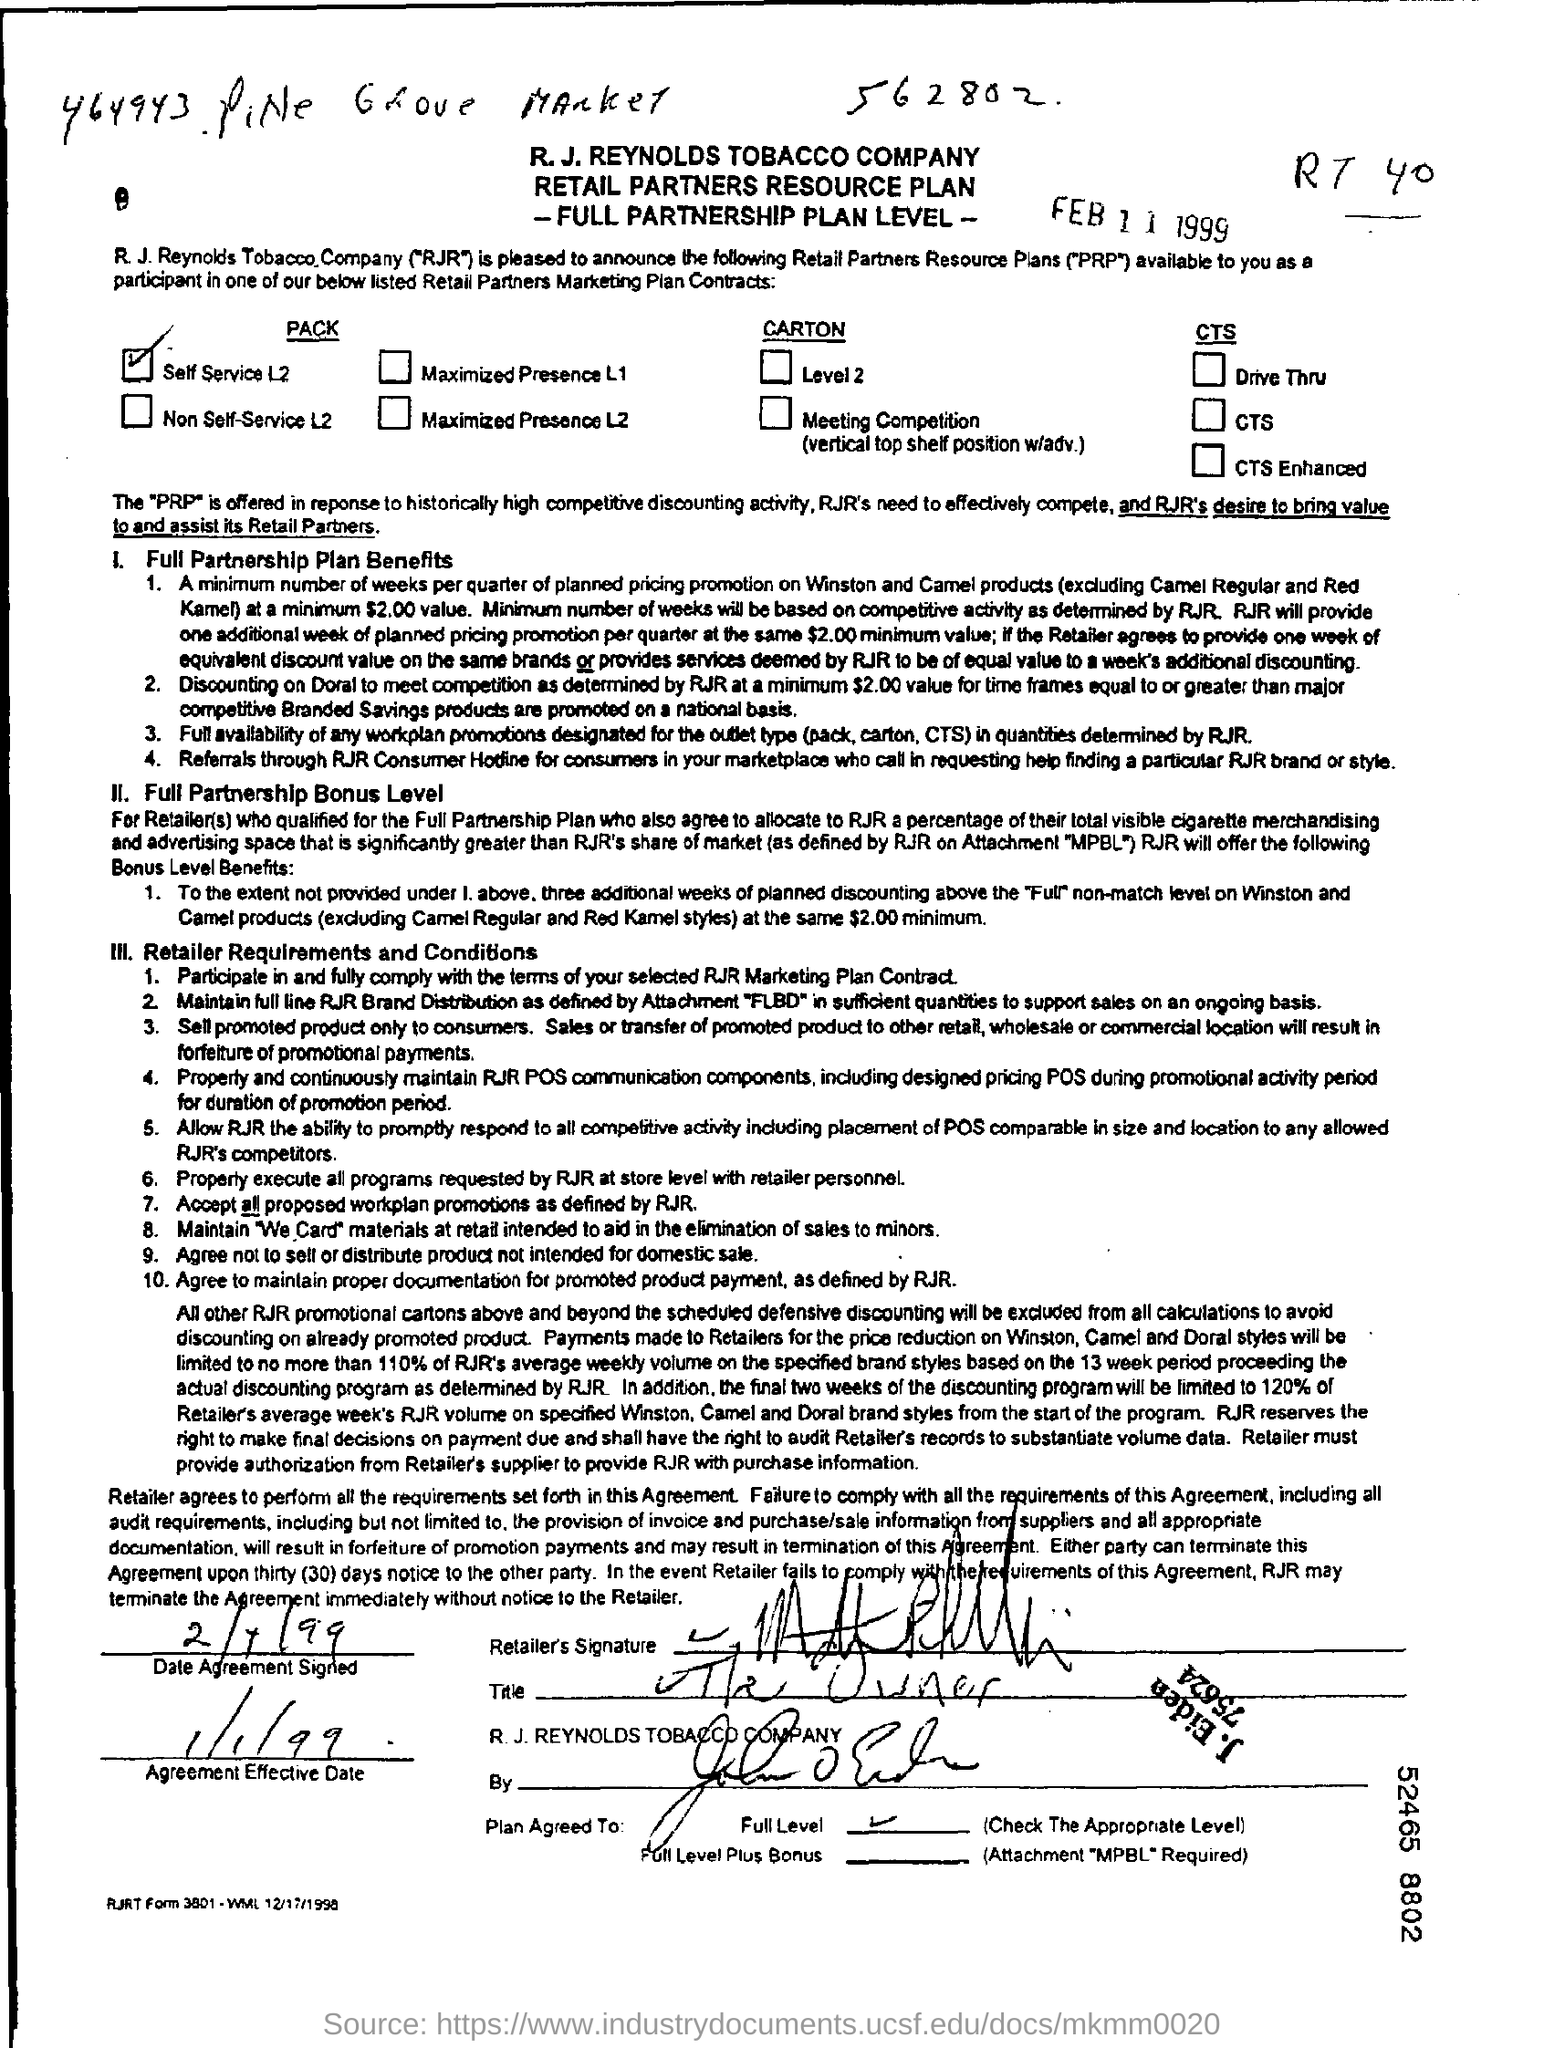What is the date printed?
Your answer should be very brief. Feb 11 1999. When is the Agreement Effective from?
Provide a short and direct response. 1/1/99. 